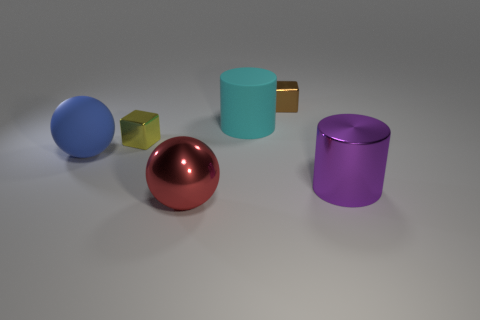Does the small cube that is behind the large cyan cylinder have the same material as the yellow block?
Your answer should be compact. Yes. There is a blue sphere that is the same size as the purple cylinder; what material is it?
Your answer should be very brief. Rubber. What number of other things are made of the same material as the blue sphere?
Provide a short and direct response. 1. Is the size of the blue rubber object the same as the block that is on the left side of the brown object?
Your answer should be compact. No. Are there fewer big matte balls behind the brown shiny cube than rubber balls that are behind the big cyan matte thing?
Your answer should be compact. No. What is the size of the ball behind the red metal sphere?
Ensure brevity in your answer.  Large. Do the purple shiny thing and the cyan cylinder have the same size?
Your response must be concise. Yes. How many objects are behind the tiny yellow metallic block and in front of the brown block?
Keep it short and to the point. 1. What number of brown objects are either matte balls or tiny metal blocks?
Offer a very short reply. 1. How many matte objects are tiny cyan cylinders or tiny brown blocks?
Offer a terse response. 0. 